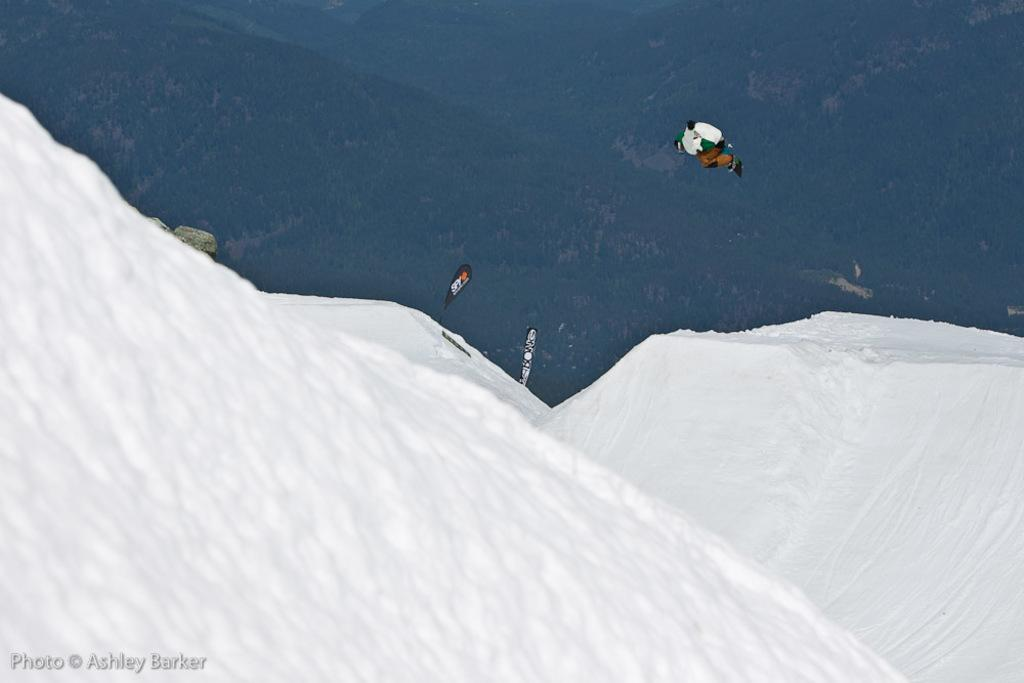What can be found in the bottom left corner of the image? There is a watermark on the bottom left of the image. What type of landscape is visible in the background of the image? There are snow mountains in the background of the image. What is the person in the image doing? There is a person in the air in the image. How many flags are present in the image? There are two flags in the image. What is the color of the sky in the image? The sky in the image is blue, and there are clouds visible. What is the son's opinion about the things in the image? There is no son present in the image, and therefore no opinion can be attributed to a son. 